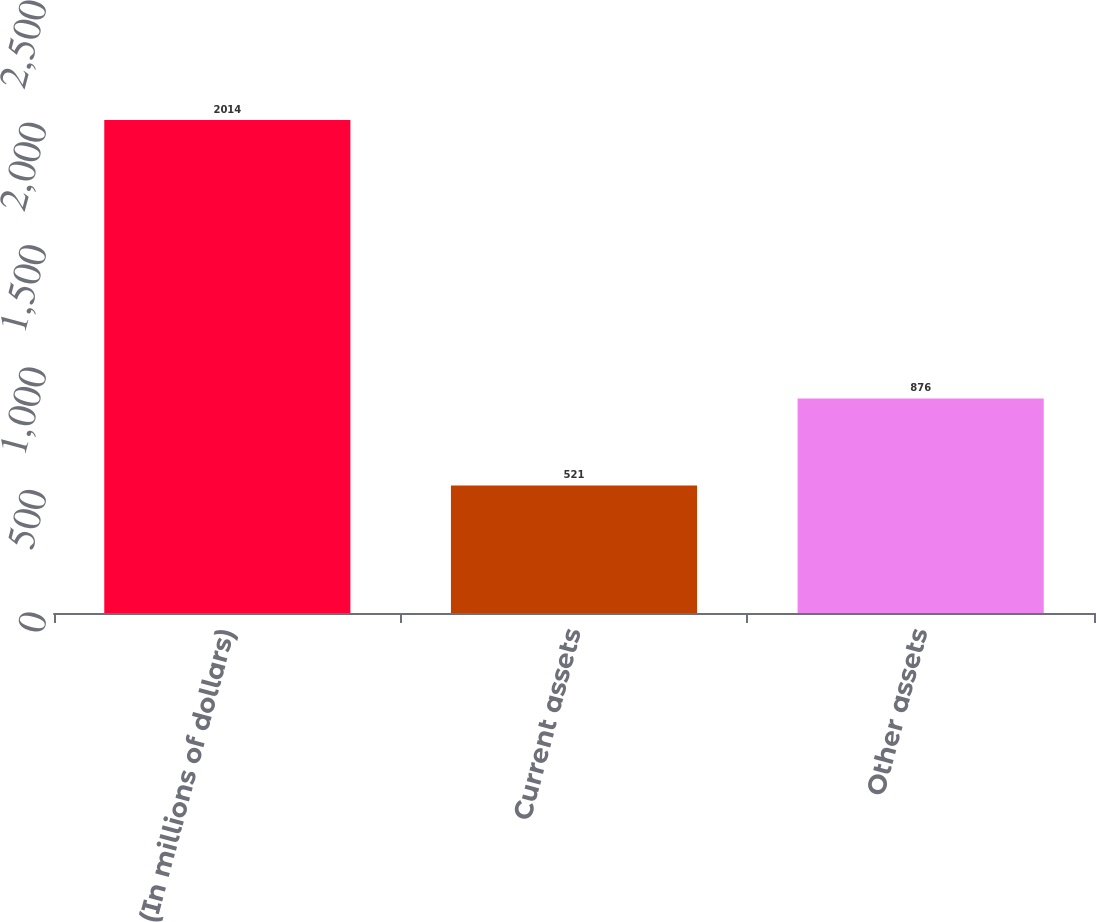Convert chart. <chart><loc_0><loc_0><loc_500><loc_500><bar_chart><fcel>(In millions of dollars)<fcel>Current assets<fcel>Other assets<nl><fcel>2014<fcel>521<fcel>876<nl></chart> 